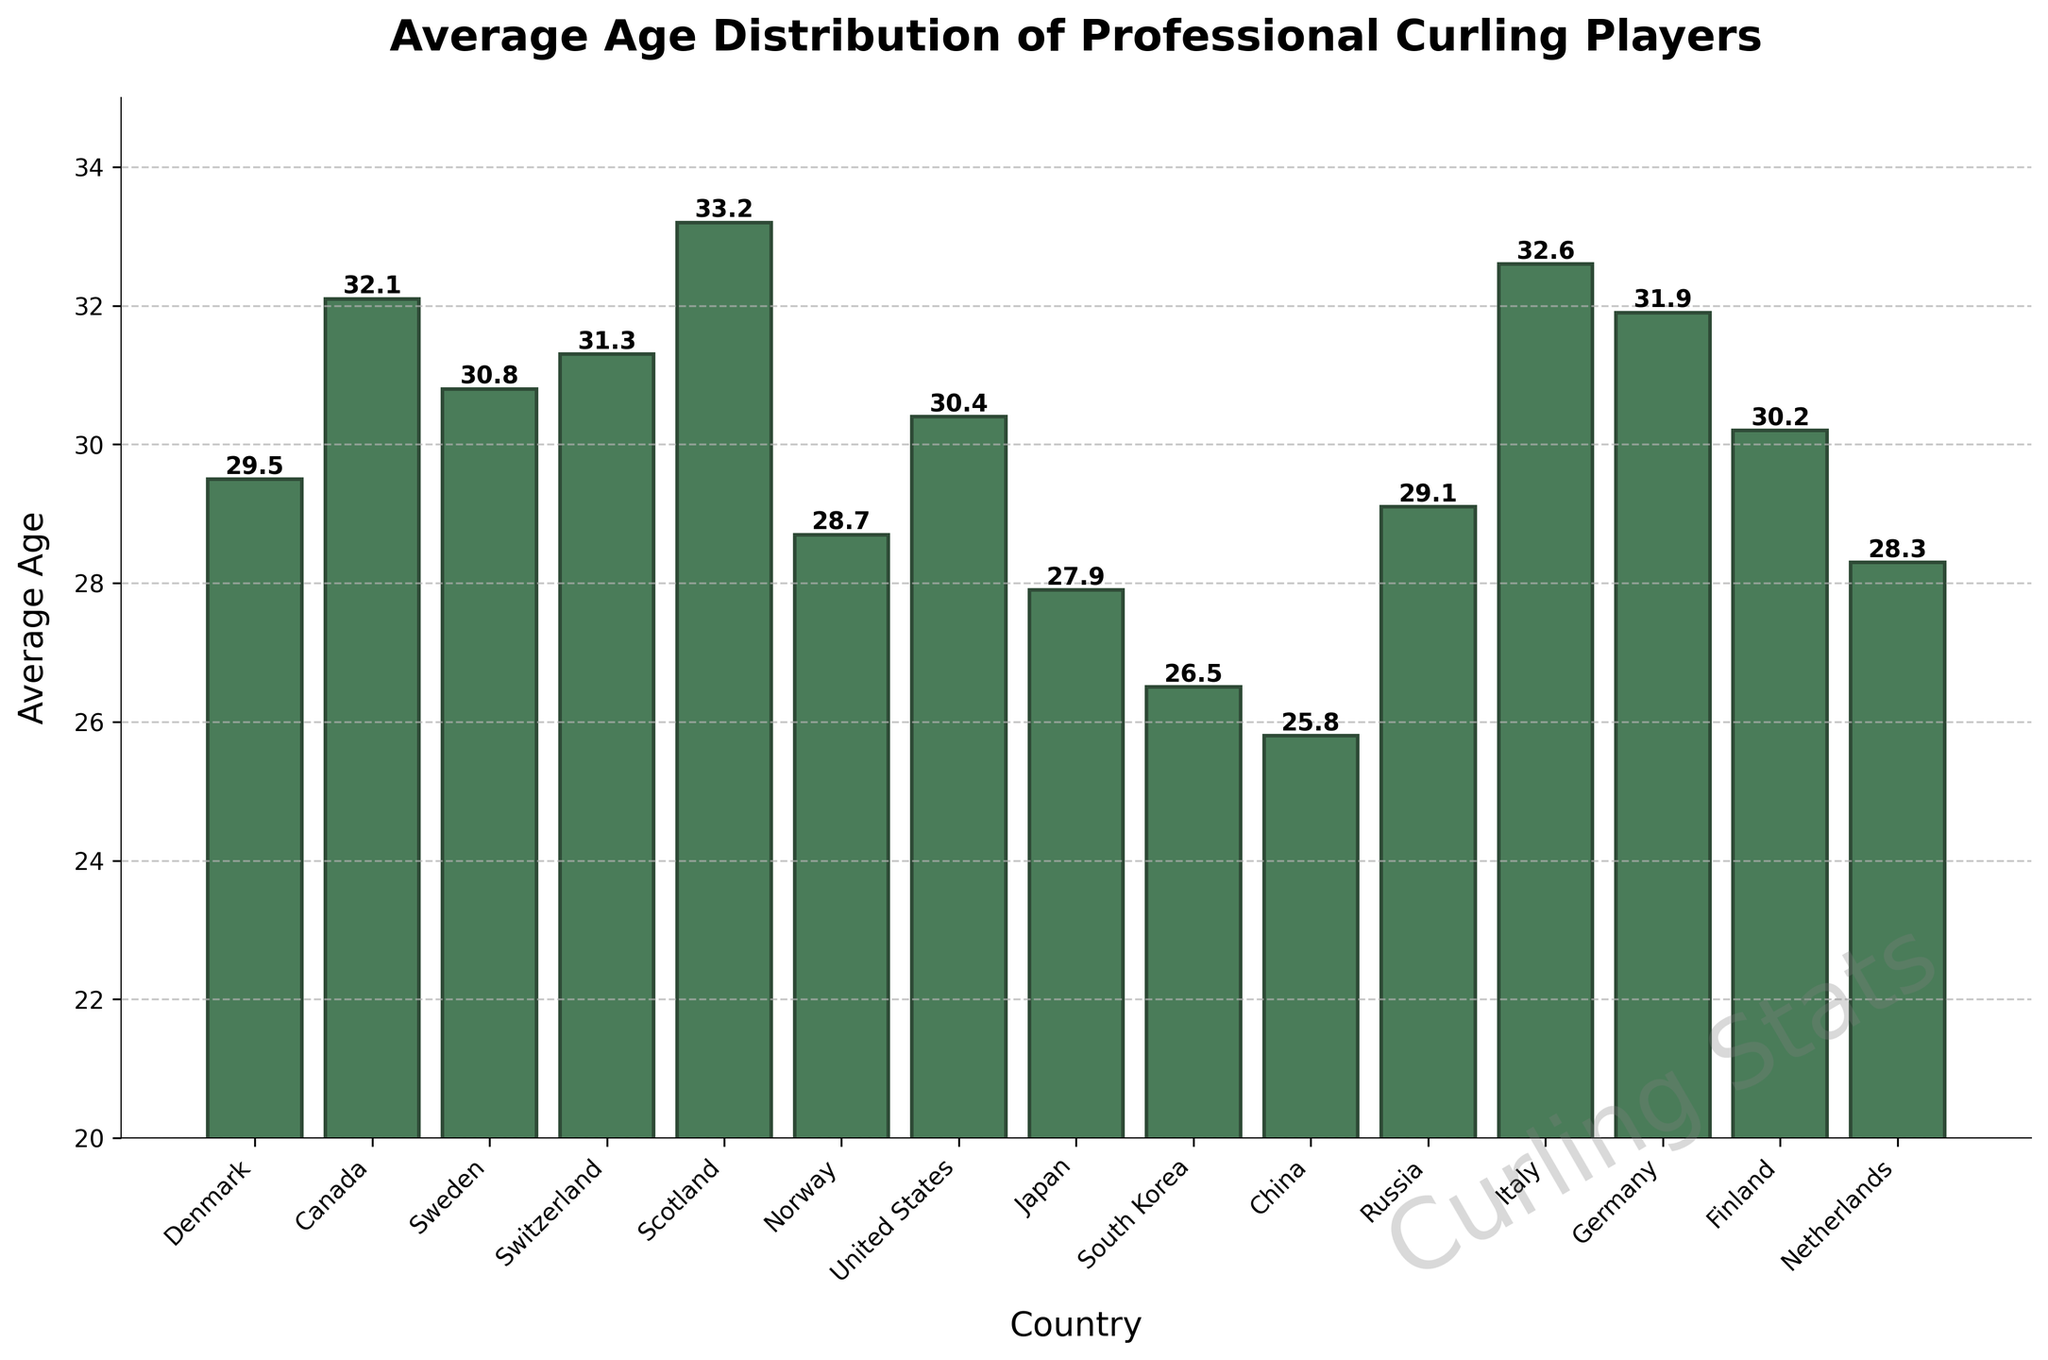Which country has the oldest average age of professional curling players? From the bar chart, the bar representing Scotland reaches the highest point on the vertical axis among all countries.
Answer: Scotland Which two countries have the youngest average ages, and what are they? South Korea and China are the countries with the lowest bars on the chart. South Korea has an average age of 26.5, and China has an average age of 25.8.
Answer: South Korea (26.5), China (25.8) What is the difference in the average age of professional curling players between Canada and Norway? Referring to the heights of the bars, Canada has an average age of 32.1 and Norway has 28.7. The difference is 32.1 - 28.7.
Answer: 3.4 What is the median average age among all the countries? First, list the average ages: 25.8, 26.5, 27.9, 28.3, 28.7, 29.1, 29.5, 30.2, 30.4, 30.8, 31.3, 31.9, 32.1, 32.6, 33.2. With 15 values, the eighth value is the median, which is 30.2.
Answer: 30.2 Which country has a higher average age, Germany or Switzerland, and by how much? Germany’s bar height corresponds to an average age of 31.9, while Switzerland’s is 31.3. The difference between these two values is 31.9 - 31.3.
Answer: Germany by 0.6 How many countries have an average age above 30 years? By counting the bars that exceed the 30-mark on the vertical axis, we find that there are 10 countries above 30 years.
Answer: 10 Compare the average ages of Denmark and Japan. Which country has the higher average age? Denmark’s bar indicates an average age of 29.5, while Japan’s indicates 27.9. Thus, Denmark has the higher average age.
Answer: Denmark What is the combined average age of the United States and Finland? The average age of the United States is 30.4, and Finland is 30.2. Adding these together gives 30.4 + 30.2.
Answer: 60.6 Which countries have average ages within the range of 28-30 years? Identifying the bars within the 28-30 range: Denmark (29.5), Norway (28.7), Russia (29.1), and Netherlands (28.3).
Answer: Denmark, Norway, Russia, Netherlands What is the average age difference between the oldest and youngest country’s players? The oldest average age is Scotland with 33.2, and the youngest is China with 25.8. The difference is 33.2 - 25.8.
Answer: 7.4 